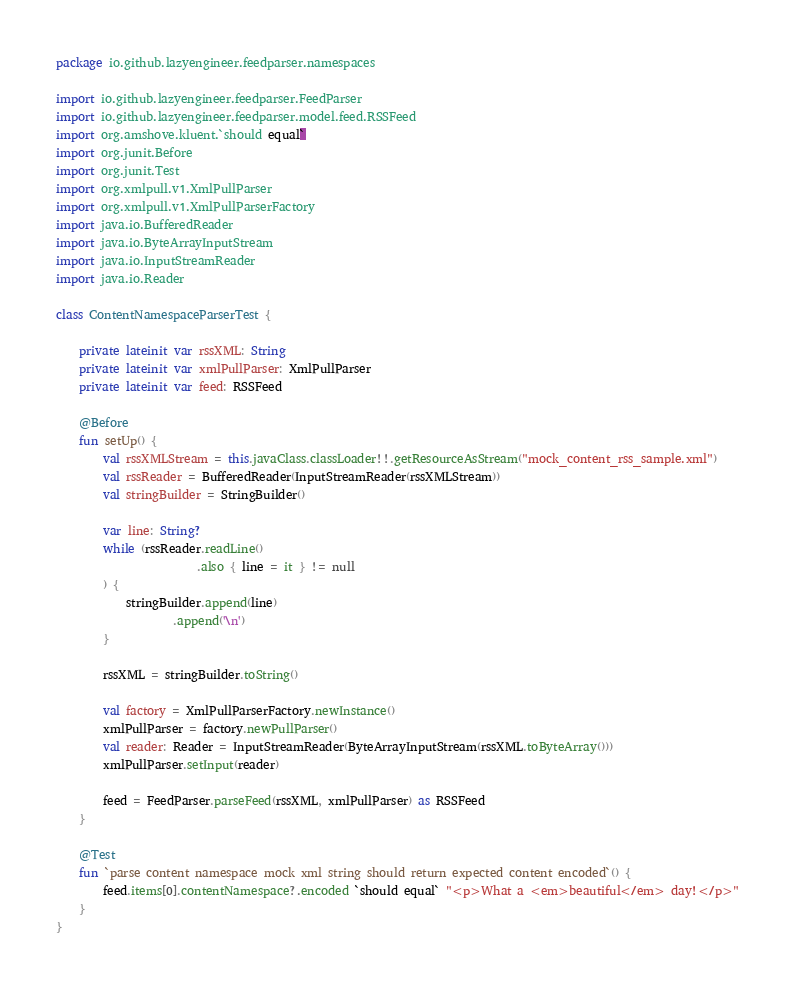<code> <loc_0><loc_0><loc_500><loc_500><_Kotlin_>package io.github.lazyengineer.feedparser.namespaces

import io.github.lazyengineer.feedparser.FeedParser
import io.github.lazyengineer.feedparser.model.feed.RSSFeed
import org.amshove.kluent.`should equal`
import org.junit.Before
import org.junit.Test
import org.xmlpull.v1.XmlPullParser
import org.xmlpull.v1.XmlPullParserFactory
import java.io.BufferedReader
import java.io.ByteArrayInputStream
import java.io.InputStreamReader
import java.io.Reader

class ContentNamespaceParserTest {

	private lateinit var rssXML: String
	private lateinit var xmlPullParser: XmlPullParser
	private lateinit var feed: RSSFeed

	@Before
	fun setUp() {
		val rssXMLStream = this.javaClass.classLoader!!.getResourceAsStream("mock_content_rss_sample.xml")
		val rssReader = BufferedReader(InputStreamReader(rssXMLStream))
		val stringBuilder = StringBuilder()

		var line: String?
		while (rssReader.readLine()
						.also { line = it } != null
		) {
			stringBuilder.append(line)
					.append('\n')
		}

		rssXML = stringBuilder.toString()

		val factory = XmlPullParserFactory.newInstance()
		xmlPullParser = factory.newPullParser()
		val reader: Reader = InputStreamReader(ByteArrayInputStream(rssXML.toByteArray()))
		xmlPullParser.setInput(reader)

		feed = FeedParser.parseFeed(rssXML, xmlPullParser) as RSSFeed
	}

	@Test
	fun `parse content namespace mock xml string should return expected content encoded`() {
		feed.items[0].contentNamespace?.encoded `should equal` "<p>What a <em>beautiful</em> day!</p>"
	}
}
</code> 